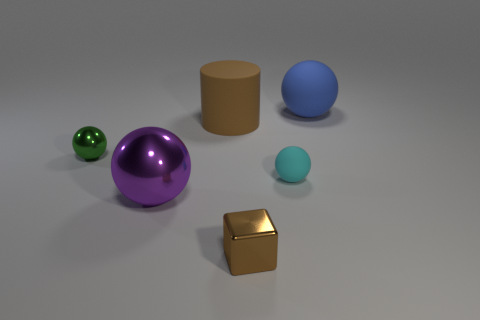How many big things are both behind the big brown rubber cylinder and to the left of the big blue object?
Offer a very short reply. 0. There is a brown object in front of the tiny object to the left of the big purple shiny thing; what is its material?
Ensure brevity in your answer.  Metal. Are there any balls that have the same material as the large purple object?
Offer a terse response. Yes. What material is the blue sphere that is the same size as the brown cylinder?
Make the answer very short. Rubber. How big is the shiny sphere on the right side of the small thing that is to the left of the big sphere that is to the left of the cyan matte sphere?
Your answer should be compact. Large. There is a brown thing that is behind the green metal thing; is there a big matte ball that is on the left side of it?
Your answer should be compact. No. Do the blue matte object and the metallic thing to the left of the purple shiny object have the same shape?
Your answer should be very brief. Yes. The metallic thing that is to the right of the big metal thing is what color?
Provide a succinct answer. Brown. What is the size of the rubber ball in front of the large matte object that is right of the big brown object?
Provide a short and direct response. Small. Does the matte object that is to the left of the cyan rubber object have the same shape as the green metal object?
Give a very brief answer. No. 